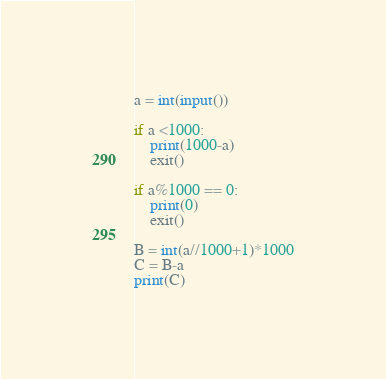Convert code to text. <code><loc_0><loc_0><loc_500><loc_500><_Python_>a = int(input())

if a <1000:
    print(1000-a)
    exit()

if a%1000 == 0:
    print(0)
    exit()

B = int(a//1000+1)*1000
C = B-a
print(C)</code> 